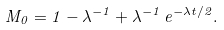Convert formula to latex. <formula><loc_0><loc_0><loc_500><loc_500>M _ { 0 } = 1 - \lambda ^ { - 1 } + \lambda ^ { - 1 } \, e ^ { - \lambda t / 2 } .</formula> 